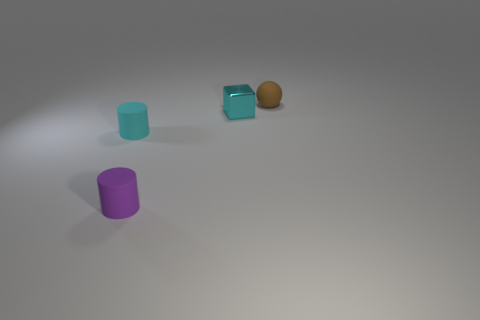Are there any other things that have the same material as the block?
Provide a succinct answer. No. Is the shape of the cyan object that is left of the small metal block the same as  the purple object?
Make the answer very short. Yes. There is a metallic cube right of the tiny cyan matte cylinder; what is its color?
Your response must be concise. Cyan. What shape is the purple object that is made of the same material as the brown ball?
Keep it short and to the point. Cylinder. Are there any other things of the same color as the small rubber sphere?
Your answer should be compact. No. Are there more tiny brown balls to the right of the tiny shiny thing than objects in front of the tiny purple thing?
Provide a short and direct response. Yes. How many brown spheres have the same size as the metal block?
Provide a short and direct response. 1. Is the number of tiny cyan matte objects that are behind the tiny ball less than the number of cylinders that are behind the purple matte thing?
Provide a short and direct response. Yes. Is there another small thing of the same shape as the small cyan rubber object?
Provide a short and direct response. Yes. Is the shape of the purple matte thing the same as the small cyan rubber object?
Provide a succinct answer. Yes. 